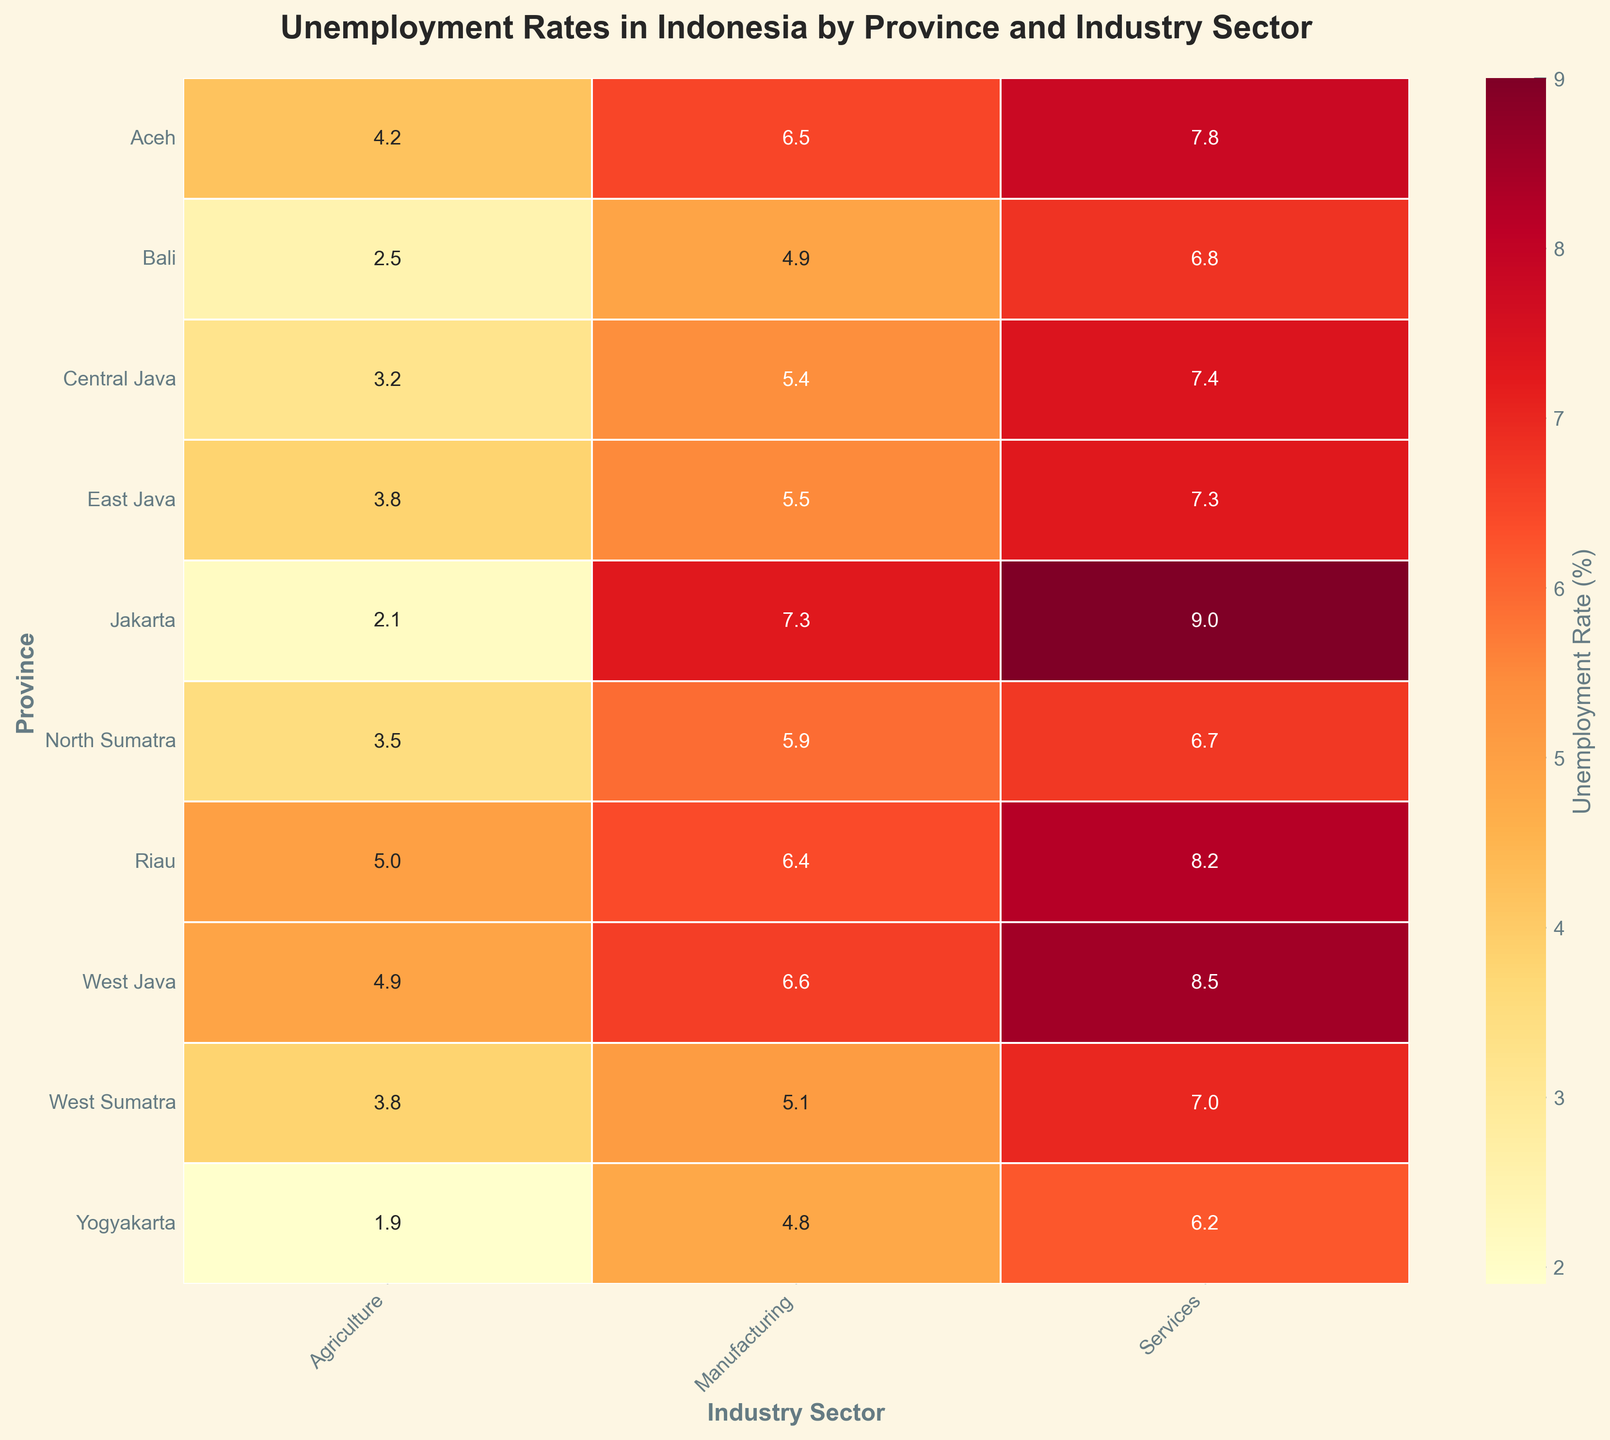What is the title of the heatmap? The title is usually placed at the top of the figure and summarizes what the visualization is about. In this case, you can read the title directly from the figure.
Answer: Unemployment Rates in Indonesia by Province and Industry Sector Which province has the highest unemployment rate in the services sector? Look at the 'Services' column in the heatmap and identify the province with the darkest shade, indicating the highest unemployment rate.
Answer: Jakarta What is the unemployment rate in the agriculture sector in Yogyakarta? Locate Yogyakarta in the 'Province' axis, and trace across to the 'Agriculture' column to read the annotated unemployment rate.
Answer: 1.9% Which industry sector has the overall highest average unemployment rate across all provinces? Calculate the average unemployment rate for each sector across all provinces: sum up the unemployment rates for each sector and divide by the number of provinces (9). Compare the averages to find the highest.
Answer: Services What is the difference in unemployment rates between the manufacturing and services sectors in West Java? Identify the unemployment rates for manufacturing and services in West Java, then subtract the manufacturing rate from the services rate.
Answer: 1.9% In which province is the unemployment rate in manufacturing the lowest? Look at the 'Manufacturing' column and identify the province with the lightest shade, indicating the lowest unemployment rate.
Answer: Yogyakarta Which provinces have an unemployment rate higher than 6.5% in the manufacturing sector? Look at the 'Manufacturing' column and identify all provinces with a number greater than 6.5% annotated.
Answer: Aceh, Jakarta, West Java How does the unemployment rate in the agriculture sector compare between Aceh and North Sumatra? Locate Aceh and North Sumatra in the 'Province' axis, then compare the values in the 'Agriculture' column for these two provinces.
Answer: Aceh has a higher rate What is the range of unemployment rates in the services sector across all provinces? Identify the minimum and maximum values in the 'Services' column, then calculate the difference between these values.
Answer: 1.9% (Yogyakarta) to 9.0% (Jakarta) 